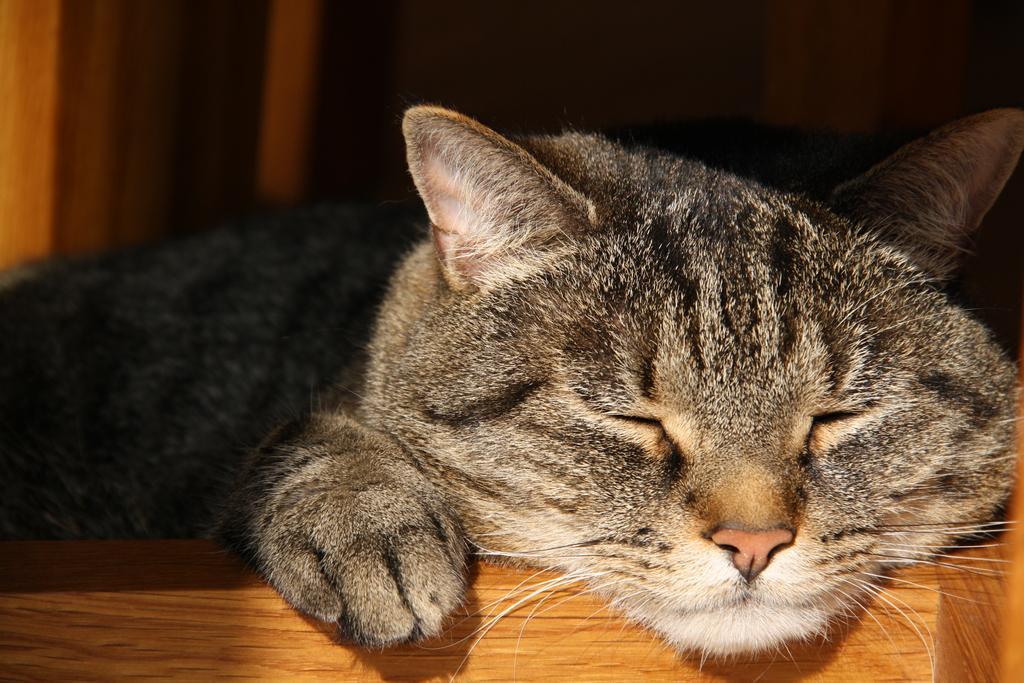Describe this image in one or two sentences. In the middle of the image there is a cat lying on the wooden surface. In this image the background is a little dark. 